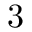<formula> <loc_0><loc_0><loc_500><loc_500>3</formula> 